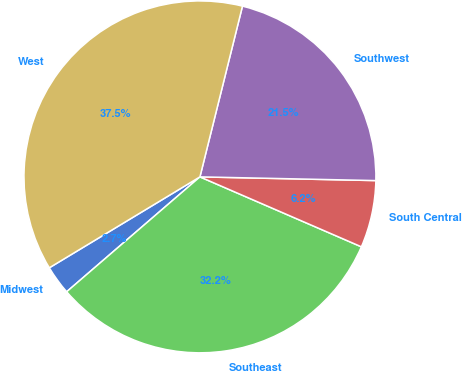Convert chart. <chart><loc_0><loc_0><loc_500><loc_500><pie_chart><fcel>Midwest<fcel>Southeast<fcel>South Central<fcel>Southwest<fcel>West<nl><fcel>2.68%<fcel>32.17%<fcel>6.17%<fcel>21.45%<fcel>37.53%<nl></chart> 